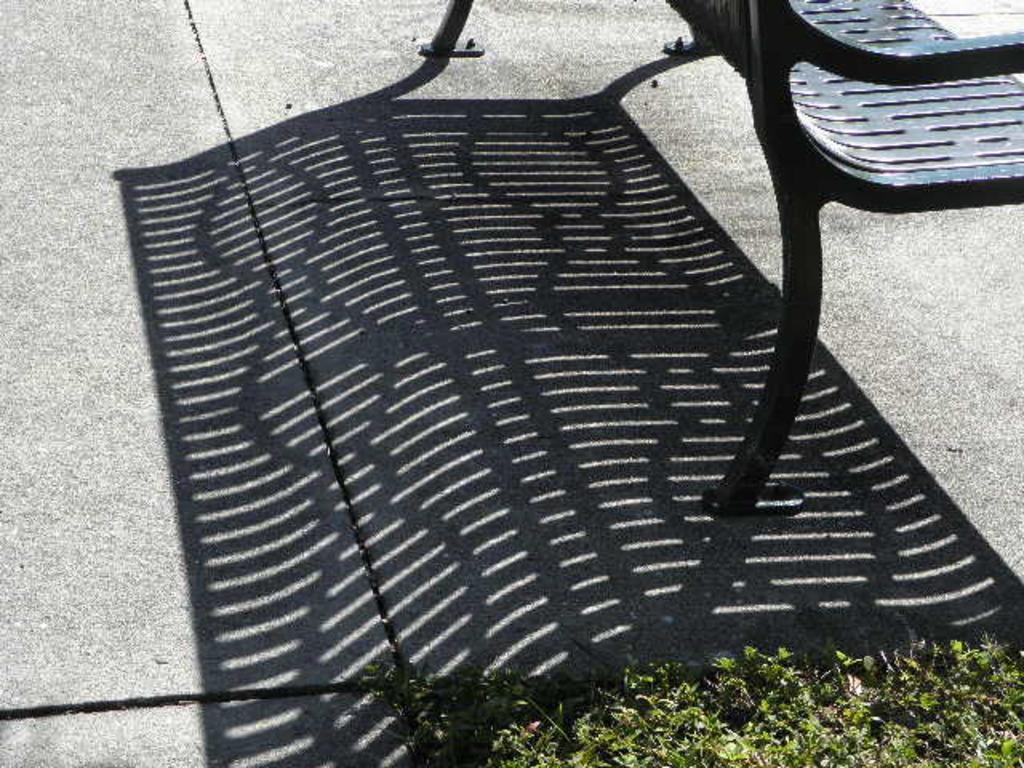Please provide a concise description of this image. This picture is clicked outside. In the foreground we can see the plants and a shadow of a bench on the ground. On the right corner there is a bench placed on the ground. 